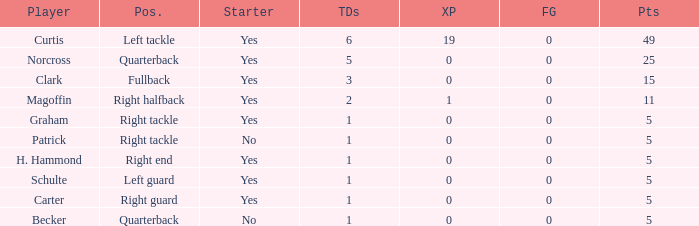Name the least touchdowns for 11 points 2.0. 